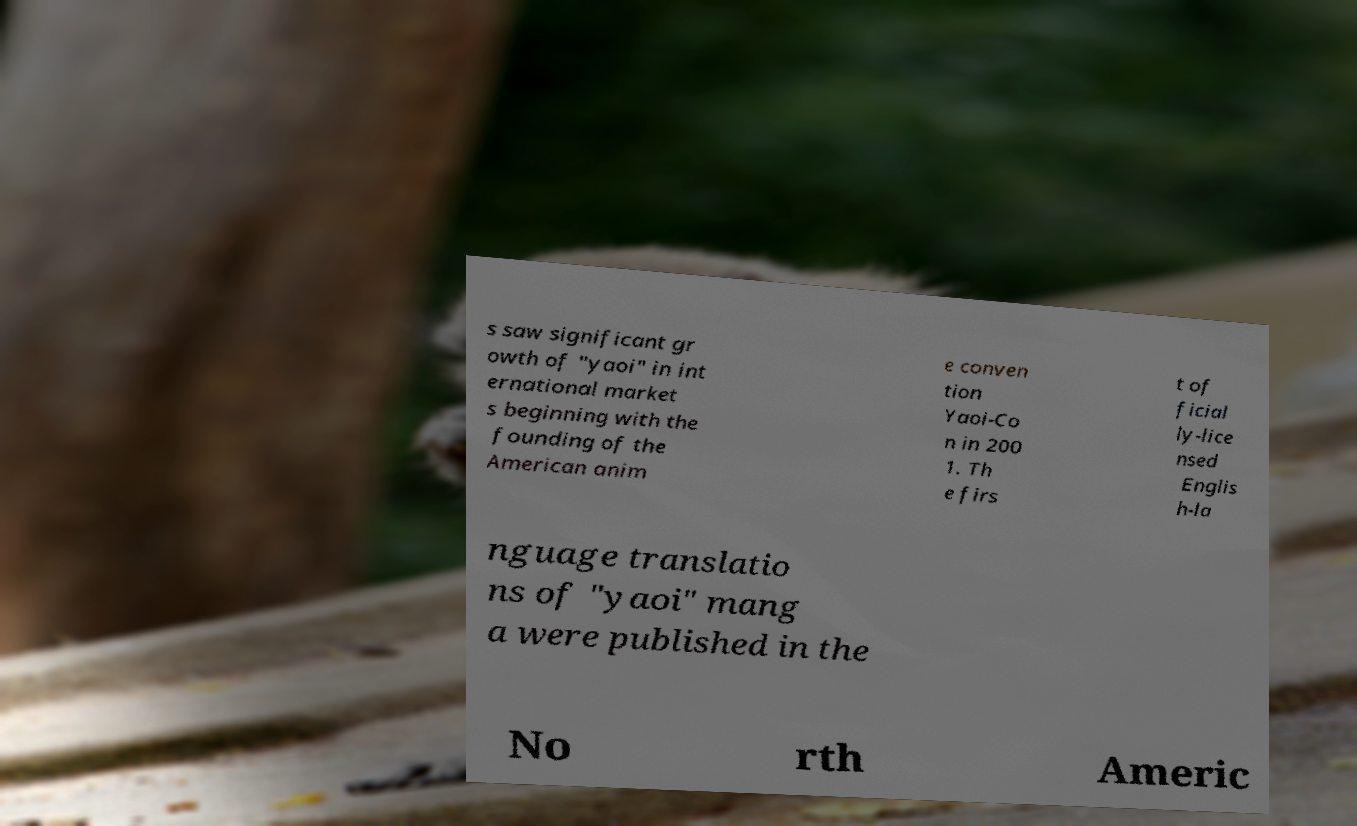Can you read and provide the text displayed in the image?This photo seems to have some interesting text. Can you extract and type it out for me? s saw significant gr owth of "yaoi" in int ernational market s beginning with the founding of the American anim e conven tion Yaoi-Co n in 200 1. Th e firs t of ficial ly-lice nsed Englis h-la nguage translatio ns of "yaoi" mang a were published in the No rth Americ 